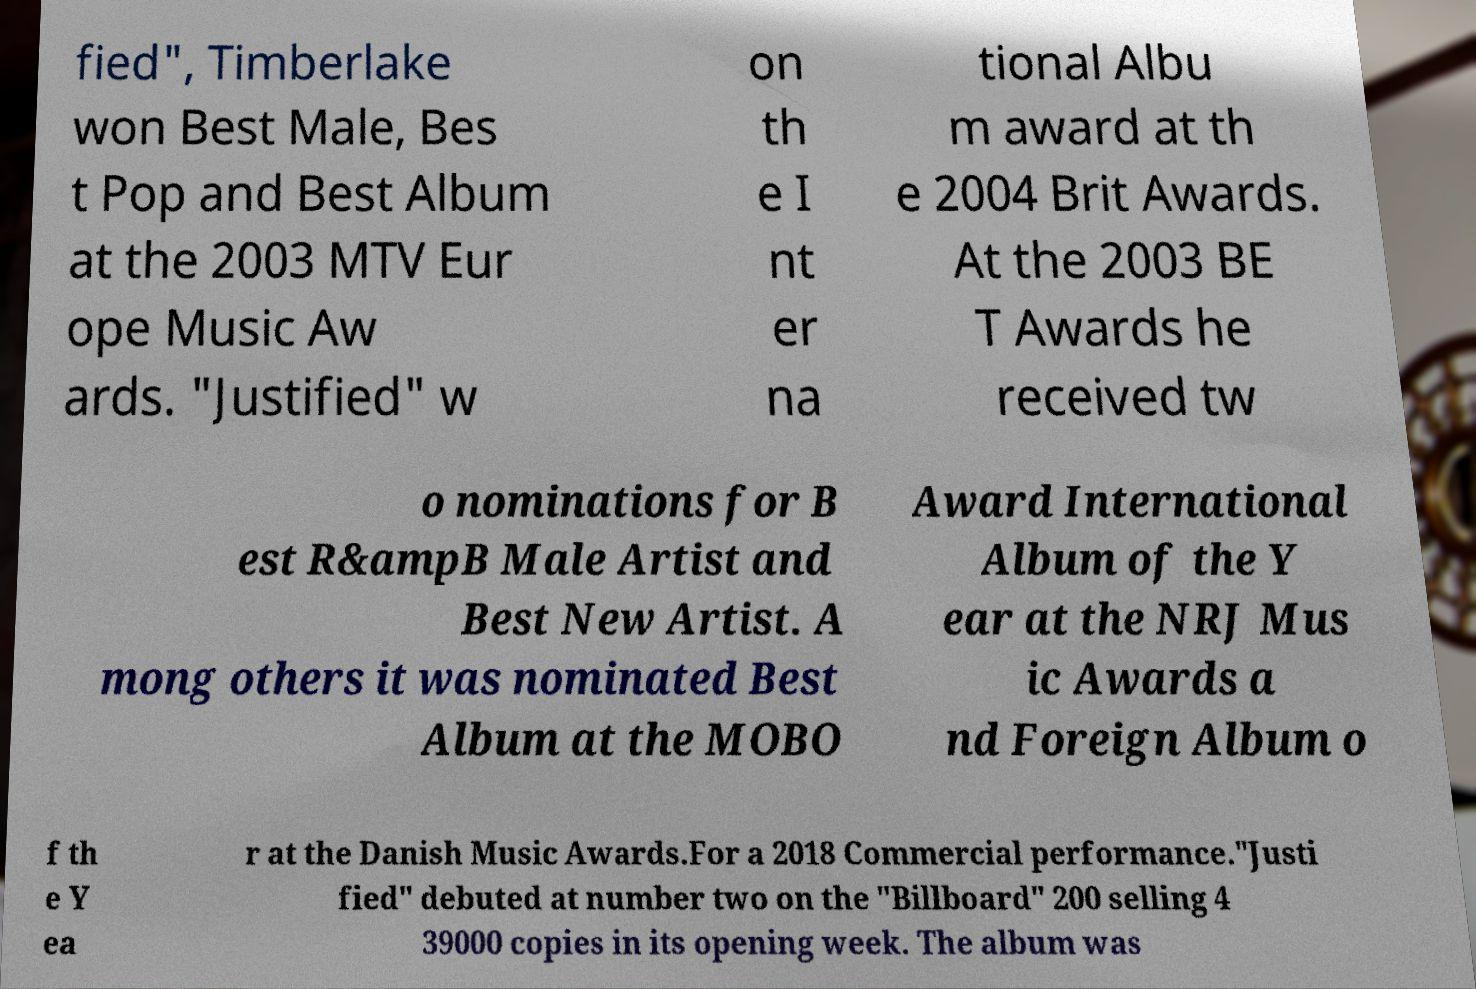There's text embedded in this image that I need extracted. Can you transcribe it verbatim? fied", Timberlake won Best Male, Bes t Pop and Best Album at the 2003 MTV Eur ope Music Aw ards. "Justified" w on th e I nt er na tional Albu m award at th e 2004 Brit Awards. At the 2003 BE T Awards he received tw o nominations for B est R&ampB Male Artist and Best New Artist. A mong others it was nominated Best Album at the MOBO Award International Album of the Y ear at the NRJ Mus ic Awards a nd Foreign Album o f th e Y ea r at the Danish Music Awards.For a 2018 Commercial performance."Justi fied" debuted at number two on the "Billboard" 200 selling 4 39000 copies in its opening week. The album was 